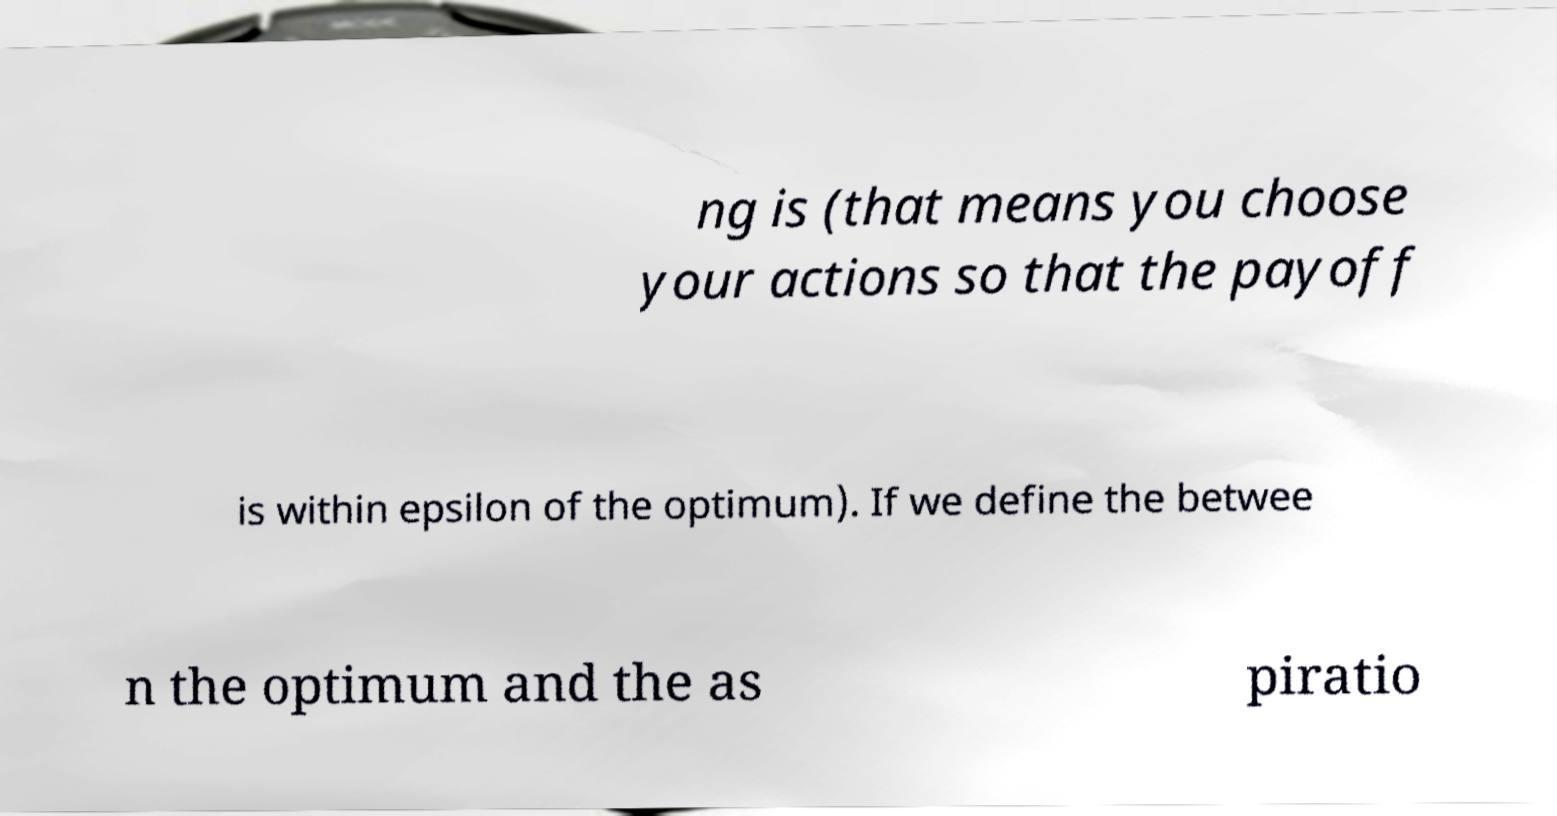Could you assist in decoding the text presented in this image and type it out clearly? ng is (that means you choose your actions so that the payoff is within epsilon of the optimum). If we define the betwee n the optimum and the as piratio 